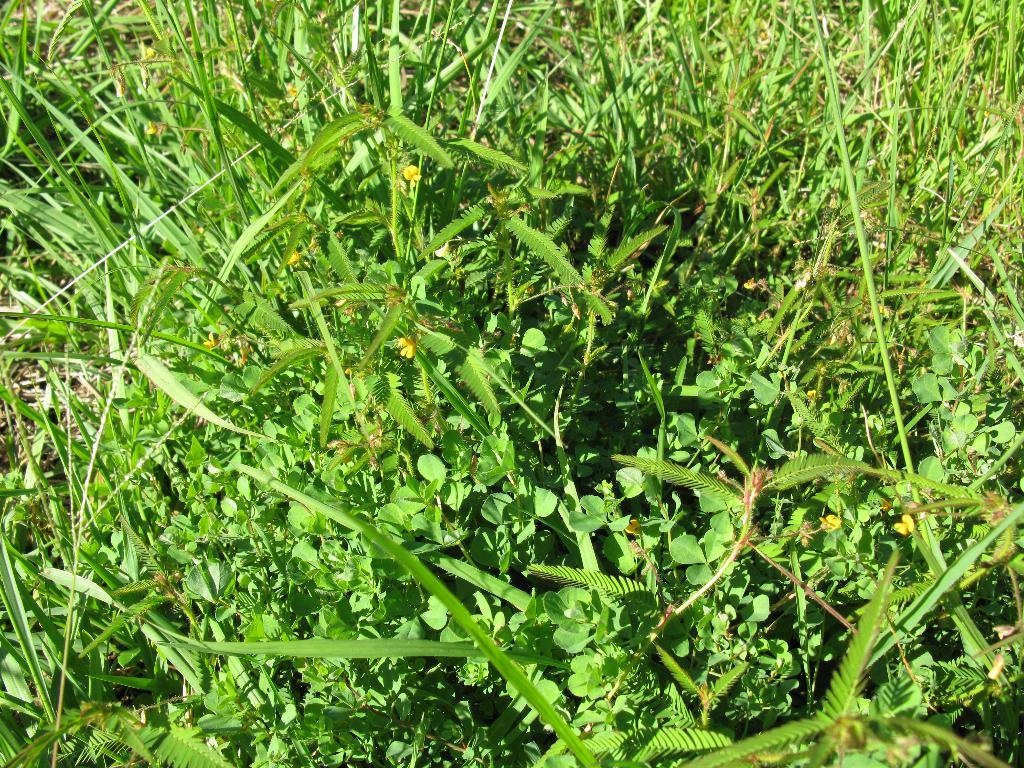What type of vegetation can be seen in the image? There is grass in the image. What other natural elements can be seen in the image? There are flowers in the image. What type of payment is required to see the fish in the image? There are no fish present in the image, so no payment is required to see them. 